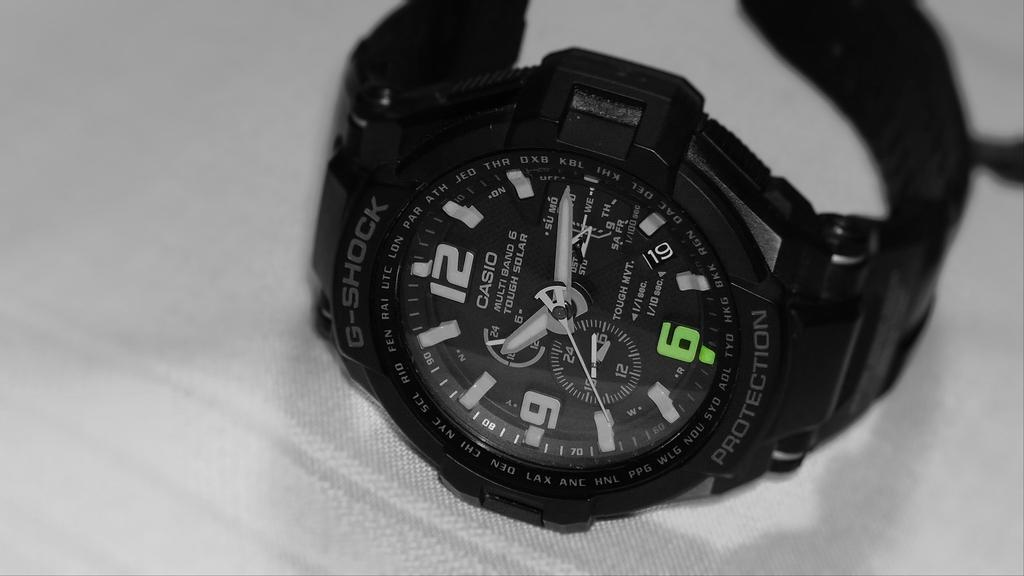<image>
Share a concise interpretation of the image provided. A black Casio wristwatch lays on its side. 